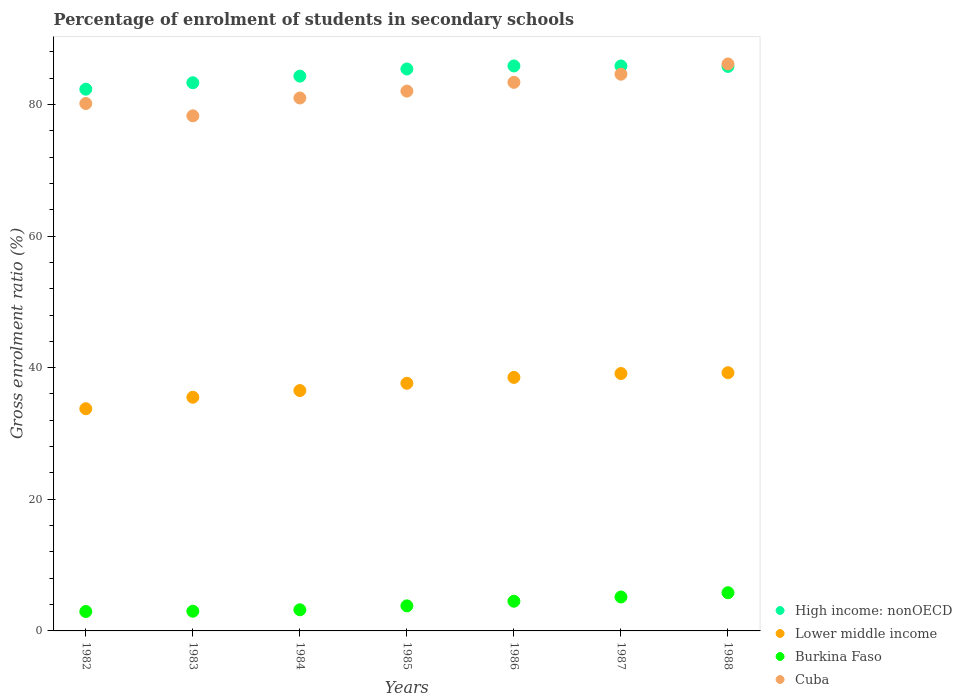How many different coloured dotlines are there?
Ensure brevity in your answer.  4. Is the number of dotlines equal to the number of legend labels?
Your answer should be very brief. Yes. What is the percentage of students enrolled in secondary schools in Burkina Faso in 1985?
Offer a terse response. 3.81. Across all years, what is the maximum percentage of students enrolled in secondary schools in Burkina Faso?
Your response must be concise. 5.81. Across all years, what is the minimum percentage of students enrolled in secondary schools in Lower middle income?
Your answer should be compact. 33.76. In which year was the percentage of students enrolled in secondary schools in Lower middle income maximum?
Provide a succinct answer. 1988. What is the total percentage of students enrolled in secondary schools in Lower middle income in the graph?
Your answer should be compact. 260.27. What is the difference between the percentage of students enrolled in secondary schools in Burkina Faso in 1983 and that in 1988?
Ensure brevity in your answer.  -2.81. What is the difference between the percentage of students enrolled in secondary schools in Cuba in 1986 and the percentage of students enrolled in secondary schools in Lower middle income in 1982?
Your answer should be compact. 49.59. What is the average percentage of students enrolled in secondary schools in High income: nonOECD per year?
Your response must be concise. 84.68. In the year 1984, what is the difference between the percentage of students enrolled in secondary schools in Cuba and percentage of students enrolled in secondary schools in Burkina Faso?
Your response must be concise. 77.76. In how many years, is the percentage of students enrolled in secondary schools in Lower middle income greater than 48 %?
Keep it short and to the point. 0. What is the ratio of the percentage of students enrolled in secondary schools in Lower middle income in 1982 to that in 1984?
Offer a very short reply. 0.92. What is the difference between the highest and the second highest percentage of students enrolled in secondary schools in High income: nonOECD?
Keep it short and to the point. 0. What is the difference between the highest and the lowest percentage of students enrolled in secondary schools in High income: nonOECD?
Offer a terse response. 3.54. Is it the case that in every year, the sum of the percentage of students enrolled in secondary schools in Cuba and percentage of students enrolled in secondary schools in High income: nonOECD  is greater than the sum of percentage of students enrolled in secondary schools in Burkina Faso and percentage of students enrolled in secondary schools in Lower middle income?
Provide a short and direct response. Yes. Is the percentage of students enrolled in secondary schools in Cuba strictly less than the percentage of students enrolled in secondary schools in Burkina Faso over the years?
Provide a succinct answer. No. How many years are there in the graph?
Your response must be concise. 7. What is the difference between two consecutive major ticks on the Y-axis?
Make the answer very short. 20. How are the legend labels stacked?
Offer a terse response. Vertical. What is the title of the graph?
Ensure brevity in your answer.  Percentage of enrolment of students in secondary schools. Does "Kenya" appear as one of the legend labels in the graph?
Provide a short and direct response. No. What is the Gross enrolment ratio (%) of High income: nonOECD in 1982?
Provide a succinct answer. 82.31. What is the Gross enrolment ratio (%) in Lower middle income in 1982?
Your response must be concise. 33.76. What is the Gross enrolment ratio (%) in Burkina Faso in 1982?
Ensure brevity in your answer.  2.95. What is the Gross enrolment ratio (%) in Cuba in 1982?
Give a very brief answer. 80.13. What is the Gross enrolment ratio (%) of High income: nonOECD in 1983?
Give a very brief answer. 83.29. What is the Gross enrolment ratio (%) in Lower middle income in 1983?
Offer a very short reply. 35.5. What is the Gross enrolment ratio (%) in Burkina Faso in 1983?
Your response must be concise. 2.99. What is the Gross enrolment ratio (%) of Cuba in 1983?
Your answer should be compact. 78.26. What is the Gross enrolment ratio (%) of High income: nonOECD in 1984?
Provide a short and direct response. 84.29. What is the Gross enrolment ratio (%) of Lower middle income in 1984?
Keep it short and to the point. 36.52. What is the Gross enrolment ratio (%) in Burkina Faso in 1984?
Provide a succinct answer. 3.21. What is the Gross enrolment ratio (%) of Cuba in 1984?
Provide a succinct answer. 80.97. What is the Gross enrolment ratio (%) of High income: nonOECD in 1985?
Your response must be concise. 85.38. What is the Gross enrolment ratio (%) of Lower middle income in 1985?
Give a very brief answer. 37.63. What is the Gross enrolment ratio (%) of Burkina Faso in 1985?
Ensure brevity in your answer.  3.81. What is the Gross enrolment ratio (%) in Cuba in 1985?
Keep it short and to the point. 82.02. What is the Gross enrolment ratio (%) of High income: nonOECD in 1986?
Keep it short and to the point. 85.84. What is the Gross enrolment ratio (%) of Lower middle income in 1986?
Provide a succinct answer. 38.52. What is the Gross enrolment ratio (%) of Burkina Faso in 1986?
Provide a succinct answer. 4.51. What is the Gross enrolment ratio (%) of Cuba in 1986?
Offer a very short reply. 83.35. What is the Gross enrolment ratio (%) in High income: nonOECD in 1987?
Provide a short and direct response. 85.84. What is the Gross enrolment ratio (%) of Lower middle income in 1987?
Your answer should be very brief. 39.11. What is the Gross enrolment ratio (%) in Burkina Faso in 1987?
Offer a very short reply. 5.16. What is the Gross enrolment ratio (%) of Cuba in 1987?
Provide a succinct answer. 84.59. What is the Gross enrolment ratio (%) in High income: nonOECD in 1988?
Keep it short and to the point. 85.77. What is the Gross enrolment ratio (%) in Lower middle income in 1988?
Your response must be concise. 39.23. What is the Gross enrolment ratio (%) in Burkina Faso in 1988?
Give a very brief answer. 5.81. What is the Gross enrolment ratio (%) in Cuba in 1988?
Offer a terse response. 86.14. Across all years, what is the maximum Gross enrolment ratio (%) in High income: nonOECD?
Offer a very short reply. 85.84. Across all years, what is the maximum Gross enrolment ratio (%) in Lower middle income?
Your response must be concise. 39.23. Across all years, what is the maximum Gross enrolment ratio (%) of Burkina Faso?
Your response must be concise. 5.81. Across all years, what is the maximum Gross enrolment ratio (%) in Cuba?
Make the answer very short. 86.14. Across all years, what is the minimum Gross enrolment ratio (%) in High income: nonOECD?
Offer a very short reply. 82.31. Across all years, what is the minimum Gross enrolment ratio (%) of Lower middle income?
Ensure brevity in your answer.  33.76. Across all years, what is the minimum Gross enrolment ratio (%) of Burkina Faso?
Ensure brevity in your answer.  2.95. Across all years, what is the minimum Gross enrolment ratio (%) of Cuba?
Keep it short and to the point. 78.26. What is the total Gross enrolment ratio (%) of High income: nonOECD in the graph?
Your answer should be compact. 592.73. What is the total Gross enrolment ratio (%) in Lower middle income in the graph?
Keep it short and to the point. 260.27. What is the total Gross enrolment ratio (%) in Burkina Faso in the graph?
Your response must be concise. 28.44. What is the total Gross enrolment ratio (%) in Cuba in the graph?
Make the answer very short. 575.47. What is the difference between the Gross enrolment ratio (%) in High income: nonOECD in 1982 and that in 1983?
Give a very brief answer. -0.98. What is the difference between the Gross enrolment ratio (%) in Lower middle income in 1982 and that in 1983?
Your answer should be very brief. -1.74. What is the difference between the Gross enrolment ratio (%) in Burkina Faso in 1982 and that in 1983?
Your answer should be compact. -0.04. What is the difference between the Gross enrolment ratio (%) of Cuba in 1982 and that in 1983?
Give a very brief answer. 1.87. What is the difference between the Gross enrolment ratio (%) in High income: nonOECD in 1982 and that in 1984?
Ensure brevity in your answer.  -1.98. What is the difference between the Gross enrolment ratio (%) of Lower middle income in 1982 and that in 1984?
Ensure brevity in your answer.  -2.76. What is the difference between the Gross enrolment ratio (%) in Burkina Faso in 1982 and that in 1984?
Your answer should be very brief. -0.26. What is the difference between the Gross enrolment ratio (%) in Cuba in 1982 and that in 1984?
Provide a succinct answer. -0.84. What is the difference between the Gross enrolment ratio (%) in High income: nonOECD in 1982 and that in 1985?
Ensure brevity in your answer.  -3.07. What is the difference between the Gross enrolment ratio (%) in Lower middle income in 1982 and that in 1985?
Make the answer very short. -3.87. What is the difference between the Gross enrolment ratio (%) of Burkina Faso in 1982 and that in 1985?
Your answer should be very brief. -0.85. What is the difference between the Gross enrolment ratio (%) in Cuba in 1982 and that in 1985?
Offer a very short reply. -1.88. What is the difference between the Gross enrolment ratio (%) of High income: nonOECD in 1982 and that in 1986?
Your response must be concise. -3.54. What is the difference between the Gross enrolment ratio (%) in Lower middle income in 1982 and that in 1986?
Provide a succinct answer. -4.76. What is the difference between the Gross enrolment ratio (%) in Burkina Faso in 1982 and that in 1986?
Make the answer very short. -1.56. What is the difference between the Gross enrolment ratio (%) in Cuba in 1982 and that in 1986?
Ensure brevity in your answer.  -3.22. What is the difference between the Gross enrolment ratio (%) in High income: nonOECD in 1982 and that in 1987?
Your answer should be compact. -3.53. What is the difference between the Gross enrolment ratio (%) in Lower middle income in 1982 and that in 1987?
Provide a short and direct response. -5.35. What is the difference between the Gross enrolment ratio (%) in Burkina Faso in 1982 and that in 1987?
Offer a terse response. -2.21. What is the difference between the Gross enrolment ratio (%) in Cuba in 1982 and that in 1987?
Keep it short and to the point. -4.45. What is the difference between the Gross enrolment ratio (%) of High income: nonOECD in 1982 and that in 1988?
Offer a very short reply. -3.46. What is the difference between the Gross enrolment ratio (%) of Lower middle income in 1982 and that in 1988?
Make the answer very short. -5.47. What is the difference between the Gross enrolment ratio (%) in Burkina Faso in 1982 and that in 1988?
Offer a terse response. -2.85. What is the difference between the Gross enrolment ratio (%) of Cuba in 1982 and that in 1988?
Give a very brief answer. -6.01. What is the difference between the Gross enrolment ratio (%) in High income: nonOECD in 1983 and that in 1984?
Make the answer very short. -1. What is the difference between the Gross enrolment ratio (%) in Lower middle income in 1983 and that in 1984?
Your answer should be compact. -1.02. What is the difference between the Gross enrolment ratio (%) of Burkina Faso in 1983 and that in 1984?
Offer a very short reply. -0.22. What is the difference between the Gross enrolment ratio (%) of Cuba in 1983 and that in 1984?
Offer a terse response. -2.71. What is the difference between the Gross enrolment ratio (%) of High income: nonOECD in 1983 and that in 1985?
Your answer should be compact. -2.09. What is the difference between the Gross enrolment ratio (%) of Lower middle income in 1983 and that in 1985?
Make the answer very short. -2.13. What is the difference between the Gross enrolment ratio (%) of Burkina Faso in 1983 and that in 1985?
Offer a very short reply. -0.81. What is the difference between the Gross enrolment ratio (%) in Cuba in 1983 and that in 1985?
Give a very brief answer. -3.76. What is the difference between the Gross enrolment ratio (%) of High income: nonOECD in 1983 and that in 1986?
Ensure brevity in your answer.  -2.55. What is the difference between the Gross enrolment ratio (%) in Lower middle income in 1983 and that in 1986?
Offer a very short reply. -3.02. What is the difference between the Gross enrolment ratio (%) of Burkina Faso in 1983 and that in 1986?
Your answer should be compact. -1.52. What is the difference between the Gross enrolment ratio (%) of Cuba in 1983 and that in 1986?
Ensure brevity in your answer.  -5.09. What is the difference between the Gross enrolment ratio (%) of High income: nonOECD in 1983 and that in 1987?
Your response must be concise. -2.55. What is the difference between the Gross enrolment ratio (%) in Lower middle income in 1983 and that in 1987?
Offer a terse response. -3.61. What is the difference between the Gross enrolment ratio (%) in Burkina Faso in 1983 and that in 1987?
Your response must be concise. -2.17. What is the difference between the Gross enrolment ratio (%) of Cuba in 1983 and that in 1987?
Provide a short and direct response. -6.32. What is the difference between the Gross enrolment ratio (%) of High income: nonOECD in 1983 and that in 1988?
Make the answer very short. -2.48. What is the difference between the Gross enrolment ratio (%) of Lower middle income in 1983 and that in 1988?
Offer a terse response. -3.73. What is the difference between the Gross enrolment ratio (%) of Burkina Faso in 1983 and that in 1988?
Provide a succinct answer. -2.81. What is the difference between the Gross enrolment ratio (%) of Cuba in 1983 and that in 1988?
Your answer should be compact. -7.88. What is the difference between the Gross enrolment ratio (%) of High income: nonOECD in 1984 and that in 1985?
Give a very brief answer. -1.09. What is the difference between the Gross enrolment ratio (%) of Lower middle income in 1984 and that in 1985?
Provide a short and direct response. -1.11. What is the difference between the Gross enrolment ratio (%) in Burkina Faso in 1984 and that in 1985?
Keep it short and to the point. -0.59. What is the difference between the Gross enrolment ratio (%) in Cuba in 1984 and that in 1985?
Provide a short and direct response. -1.04. What is the difference between the Gross enrolment ratio (%) of High income: nonOECD in 1984 and that in 1986?
Give a very brief answer. -1.55. What is the difference between the Gross enrolment ratio (%) in Lower middle income in 1984 and that in 1986?
Offer a very short reply. -2. What is the difference between the Gross enrolment ratio (%) of Burkina Faso in 1984 and that in 1986?
Provide a short and direct response. -1.3. What is the difference between the Gross enrolment ratio (%) of Cuba in 1984 and that in 1986?
Offer a very short reply. -2.38. What is the difference between the Gross enrolment ratio (%) in High income: nonOECD in 1984 and that in 1987?
Your response must be concise. -1.55. What is the difference between the Gross enrolment ratio (%) of Lower middle income in 1984 and that in 1987?
Offer a terse response. -2.59. What is the difference between the Gross enrolment ratio (%) of Burkina Faso in 1984 and that in 1987?
Provide a succinct answer. -1.94. What is the difference between the Gross enrolment ratio (%) in Cuba in 1984 and that in 1987?
Your response must be concise. -3.61. What is the difference between the Gross enrolment ratio (%) of High income: nonOECD in 1984 and that in 1988?
Your answer should be compact. -1.48. What is the difference between the Gross enrolment ratio (%) of Lower middle income in 1984 and that in 1988?
Ensure brevity in your answer.  -2.71. What is the difference between the Gross enrolment ratio (%) of Burkina Faso in 1984 and that in 1988?
Offer a terse response. -2.59. What is the difference between the Gross enrolment ratio (%) in Cuba in 1984 and that in 1988?
Your answer should be very brief. -5.17. What is the difference between the Gross enrolment ratio (%) in High income: nonOECD in 1985 and that in 1986?
Your response must be concise. -0.46. What is the difference between the Gross enrolment ratio (%) in Lower middle income in 1985 and that in 1986?
Provide a short and direct response. -0.89. What is the difference between the Gross enrolment ratio (%) of Burkina Faso in 1985 and that in 1986?
Ensure brevity in your answer.  -0.71. What is the difference between the Gross enrolment ratio (%) in Cuba in 1985 and that in 1986?
Provide a succinct answer. -1.33. What is the difference between the Gross enrolment ratio (%) of High income: nonOECD in 1985 and that in 1987?
Give a very brief answer. -0.46. What is the difference between the Gross enrolment ratio (%) of Lower middle income in 1985 and that in 1987?
Your response must be concise. -1.48. What is the difference between the Gross enrolment ratio (%) in Burkina Faso in 1985 and that in 1987?
Make the answer very short. -1.35. What is the difference between the Gross enrolment ratio (%) in Cuba in 1985 and that in 1987?
Provide a short and direct response. -2.57. What is the difference between the Gross enrolment ratio (%) of High income: nonOECD in 1985 and that in 1988?
Provide a succinct answer. -0.39. What is the difference between the Gross enrolment ratio (%) of Lower middle income in 1985 and that in 1988?
Offer a very short reply. -1.61. What is the difference between the Gross enrolment ratio (%) of Burkina Faso in 1985 and that in 1988?
Offer a very short reply. -2. What is the difference between the Gross enrolment ratio (%) in Cuba in 1985 and that in 1988?
Offer a very short reply. -4.13. What is the difference between the Gross enrolment ratio (%) in High income: nonOECD in 1986 and that in 1987?
Offer a very short reply. 0.01. What is the difference between the Gross enrolment ratio (%) in Lower middle income in 1986 and that in 1987?
Provide a short and direct response. -0.59. What is the difference between the Gross enrolment ratio (%) in Burkina Faso in 1986 and that in 1987?
Offer a very short reply. -0.64. What is the difference between the Gross enrolment ratio (%) of Cuba in 1986 and that in 1987?
Make the answer very short. -1.23. What is the difference between the Gross enrolment ratio (%) in High income: nonOECD in 1986 and that in 1988?
Offer a terse response. 0.07. What is the difference between the Gross enrolment ratio (%) of Lower middle income in 1986 and that in 1988?
Make the answer very short. -0.71. What is the difference between the Gross enrolment ratio (%) of Burkina Faso in 1986 and that in 1988?
Give a very brief answer. -1.29. What is the difference between the Gross enrolment ratio (%) in Cuba in 1986 and that in 1988?
Provide a succinct answer. -2.79. What is the difference between the Gross enrolment ratio (%) of High income: nonOECD in 1987 and that in 1988?
Provide a succinct answer. 0.07. What is the difference between the Gross enrolment ratio (%) of Lower middle income in 1987 and that in 1988?
Make the answer very short. -0.12. What is the difference between the Gross enrolment ratio (%) of Burkina Faso in 1987 and that in 1988?
Make the answer very short. -0.65. What is the difference between the Gross enrolment ratio (%) of Cuba in 1987 and that in 1988?
Keep it short and to the point. -1.56. What is the difference between the Gross enrolment ratio (%) of High income: nonOECD in 1982 and the Gross enrolment ratio (%) of Lower middle income in 1983?
Your answer should be compact. 46.81. What is the difference between the Gross enrolment ratio (%) in High income: nonOECD in 1982 and the Gross enrolment ratio (%) in Burkina Faso in 1983?
Ensure brevity in your answer.  79.32. What is the difference between the Gross enrolment ratio (%) in High income: nonOECD in 1982 and the Gross enrolment ratio (%) in Cuba in 1983?
Give a very brief answer. 4.05. What is the difference between the Gross enrolment ratio (%) of Lower middle income in 1982 and the Gross enrolment ratio (%) of Burkina Faso in 1983?
Offer a terse response. 30.77. What is the difference between the Gross enrolment ratio (%) in Lower middle income in 1982 and the Gross enrolment ratio (%) in Cuba in 1983?
Make the answer very short. -44.5. What is the difference between the Gross enrolment ratio (%) in Burkina Faso in 1982 and the Gross enrolment ratio (%) in Cuba in 1983?
Your response must be concise. -75.31. What is the difference between the Gross enrolment ratio (%) in High income: nonOECD in 1982 and the Gross enrolment ratio (%) in Lower middle income in 1984?
Ensure brevity in your answer.  45.79. What is the difference between the Gross enrolment ratio (%) of High income: nonOECD in 1982 and the Gross enrolment ratio (%) of Burkina Faso in 1984?
Provide a succinct answer. 79.1. What is the difference between the Gross enrolment ratio (%) in High income: nonOECD in 1982 and the Gross enrolment ratio (%) in Cuba in 1984?
Keep it short and to the point. 1.34. What is the difference between the Gross enrolment ratio (%) of Lower middle income in 1982 and the Gross enrolment ratio (%) of Burkina Faso in 1984?
Your answer should be very brief. 30.55. What is the difference between the Gross enrolment ratio (%) in Lower middle income in 1982 and the Gross enrolment ratio (%) in Cuba in 1984?
Ensure brevity in your answer.  -47.21. What is the difference between the Gross enrolment ratio (%) of Burkina Faso in 1982 and the Gross enrolment ratio (%) of Cuba in 1984?
Provide a succinct answer. -78.02. What is the difference between the Gross enrolment ratio (%) in High income: nonOECD in 1982 and the Gross enrolment ratio (%) in Lower middle income in 1985?
Provide a succinct answer. 44.68. What is the difference between the Gross enrolment ratio (%) in High income: nonOECD in 1982 and the Gross enrolment ratio (%) in Burkina Faso in 1985?
Keep it short and to the point. 78.5. What is the difference between the Gross enrolment ratio (%) in High income: nonOECD in 1982 and the Gross enrolment ratio (%) in Cuba in 1985?
Provide a succinct answer. 0.29. What is the difference between the Gross enrolment ratio (%) of Lower middle income in 1982 and the Gross enrolment ratio (%) of Burkina Faso in 1985?
Offer a terse response. 29.96. What is the difference between the Gross enrolment ratio (%) in Lower middle income in 1982 and the Gross enrolment ratio (%) in Cuba in 1985?
Your response must be concise. -48.26. What is the difference between the Gross enrolment ratio (%) of Burkina Faso in 1982 and the Gross enrolment ratio (%) of Cuba in 1985?
Keep it short and to the point. -79.07. What is the difference between the Gross enrolment ratio (%) in High income: nonOECD in 1982 and the Gross enrolment ratio (%) in Lower middle income in 1986?
Offer a terse response. 43.79. What is the difference between the Gross enrolment ratio (%) in High income: nonOECD in 1982 and the Gross enrolment ratio (%) in Burkina Faso in 1986?
Give a very brief answer. 77.8. What is the difference between the Gross enrolment ratio (%) of High income: nonOECD in 1982 and the Gross enrolment ratio (%) of Cuba in 1986?
Provide a succinct answer. -1.04. What is the difference between the Gross enrolment ratio (%) of Lower middle income in 1982 and the Gross enrolment ratio (%) of Burkina Faso in 1986?
Make the answer very short. 29.25. What is the difference between the Gross enrolment ratio (%) of Lower middle income in 1982 and the Gross enrolment ratio (%) of Cuba in 1986?
Offer a terse response. -49.59. What is the difference between the Gross enrolment ratio (%) in Burkina Faso in 1982 and the Gross enrolment ratio (%) in Cuba in 1986?
Provide a succinct answer. -80.4. What is the difference between the Gross enrolment ratio (%) of High income: nonOECD in 1982 and the Gross enrolment ratio (%) of Lower middle income in 1987?
Keep it short and to the point. 43.2. What is the difference between the Gross enrolment ratio (%) of High income: nonOECD in 1982 and the Gross enrolment ratio (%) of Burkina Faso in 1987?
Your response must be concise. 77.15. What is the difference between the Gross enrolment ratio (%) of High income: nonOECD in 1982 and the Gross enrolment ratio (%) of Cuba in 1987?
Offer a terse response. -2.28. What is the difference between the Gross enrolment ratio (%) in Lower middle income in 1982 and the Gross enrolment ratio (%) in Burkina Faso in 1987?
Keep it short and to the point. 28.6. What is the difference between the Gross enrolment ratio (%) of Lower middle income in 1982 and the Gross enrolment ratio (%) of Cuba in 1987?
Ensure brevity in your answer.  -50.82. What is the difference between the Gross enrolment ratio (%) of Burkina Faso in 1982 and the Gross enrolment ratio (%) of Cuba in 1987?
Offer a terse response. -81.63. What is the difference between the Gross enrolment ratio (%) of High income: nonOECD in 1982 and the Gross enrolment ratio (%) of Lower middle income in 1988?
Offer a very short reply. 43.08. What is the difference between the Gross enrolment ratio (%) of High income: nonOECD in 1982 and the Gross enrolment ratio (%) of Burkina Faso in 1988?
Provide a succinct answer. 76.5. What is the difference between the Gross enrolment ratio (%) of High income: nonOECD in 1982 and the Gross enrolment ratio (%) of Cuba in 1988?
Keep it short and to the point. -3.83. What is the difference between the Gross enrolment ratio (%) of Lower middle income in 1982 and the Gross enrolment ratio (%) of Burkina Faso in 1988?
Offer a very short reply. 27.96. What is the difference between the Gross enrolment ratio (%) in Lower middle income in 1982 and the Gross enrolment ratio (%) in Cuba in 1988?
Provide a short and direct response. -52.38. What is the difference between the Gross enrolment ratio (%) of Burkina Faso in 1982 and the Gross enrolment ratio (%) of Cuba in 1988?
Make the answer very short. -83.19. What is the difference between the Gross enrolment ratio (%) of High income: nonOECD in 1983 and the Gross enrolment ratio (%) of Lower middle income in 1984?
Make the answer very short. 46.77. What is the difference between the Gross enrolment ratio (%) in High income: nonOECD in 1983 and the Gross enrolment ratio (%) in Burkina Faso in 1984?
Keep it short and to the point. 80.08. What is the difference between the Gross enrolment ratio (%) of High income: nonOECD in 1983 and the Gross enrolment ratio (%) of Cuba in 1984?
Offer a terse response. 2.32. What is the difference between the Gross enrolment ratio (%) in Lower middle income in 1983 and the Gross enrolment ratio (%) in Burkina Faso in 1984?
Your answer should be very brief. 32.29. What is the difference between the Gross enrolment ratio (%) of Lower middle income in 1983 and the Gross enrolment ratio (%) of Cuba in 1984?
Provide a short and direct response. -45.47. What is the difference between the Gross enrolment ratio (%) in Burkina Faso in 1983 and the Gross enrolment ratio (%) in Cuba in 1984?
Offer a terse response. -77.98. What is the difference between the Gross enrolment ratio (%) of High income: nonOECD in 1983 and the Gross enrolment ratio (%) of Lower middle income in 1985?
Offer a very short reply. 45.66. What is the difference between the Gross enrolment ratio (%) of High income: nonOECD in 1983 and the Gross enrolment ratio (%) of Burkina Faso in 1985?
Offer a terse response. 79.48. What is the difference between the Gross enrolment ratio (%) in High income: nonOECD in 1983 and the Gross enrolment ratio (%) in Cuba in 1985?
Make the answer very short. 1.27. What is the difference between the Gross enrolment ratio (%) in Lower middle income in 1983 and the Gross enrolment ratio (%) in Burkina Faso in 1985?
Keep it short and to the point. 31.7. What is the difference between the Gross enrolment ratio (%) of Lower middle income in 1983 and the Gross enrolment ratio (%) of Cuba in 1985?
Your answer should be compact. -46.52. What is the difference between the Gross enrolment ratio (%) of Burkina Faso in 1983 and the Gross enrolment ratio (%) of Cuba in 1985?
Provide a short and direct response. -79.03. What is the difference between the Gross enrolment ratio (%) of High income: nonOECD in 1983 and the Gross enrolment ratio (%) of Lower middle income in 1986?
Ensure brevity in your answer.  44.77. What is the difference between the Gross enrolment ratio (%) of High income: nonOECD in 1983 and the Gross enrolment ratio (%) of Burkina Faso in 1986?
Your answer should be compact. 78.78. What is the difference between the Gross enrolment ratio (%) of High income: nonOECD in 1983 and the Gross enrolment ratio (%) of Cuba in 1986?
Offer a very short reply. -0.06. What is the difference between the Gross enrolment ratio (%) in Lower middle income in 1983 and the Gross enrolment ratio (%) in Burkina Faso in 1986?
Your response must be concise. 30.99. What is the difference between the Gross enrolment ratio (%) in Lower middle income in 1983 and the Gross enrolment ratio (%) in Cuba in 1986?
Offer a terse response. -47.85. What is the difference between the Gross enrolment ratio (%) of Burkina Faso in 1983 and the Gross enrolment ratio (%) of Cuba in 1986?
Offer a terse response. -80.36. What is the difference between the Gross enrolment ratio (%) of High income: nonOECD in 1983 and the Gross enrolment ratio (%) of Lower middle income in 1987?
Offer a terse response. 44.18. What is the difference between the Gross enrolment ratio (%) of High income: nonOECD in 1983 and the Gross enrolment ratio (%) of Burkina Faso in 1987?
Give a very brief answer. 78.13. What is the difference between the Gross enrolment ratio (%) of High income: nonOECD in 1983 and the Gross enrolment ratio (%) of Cuba in 1987?
Your response must be concise. -1.3. What is the difference between the Gross enrolment ratio (%) in Lower middle income in 1983 and the Gross enrolment ratio (%) in Burkina Faso in 1987?
Provide a succinct answer. 30.34. What is the difference between the Gross enrolment ratio (%) of Lower middle income in 1983 and the Gross enrolment ratio (%) of Cuba in 1987?
Offer a very short reply. -49.08. What is the difference between the Gross enrolment ratio (%) in Burkina Faso in 1983 and the Gross enrolment ratio (%) in Cuba in 1987?
Ensure brevity in your answer.  -81.59. What is the difference between the Gross enrolment ratio (%) of High income: nonOECD in 1983 and the Gross enrolment ratio (%) of Lower middle income in 1988?
Provide a short and direct response. 44.06. What is the difference between the Gross enrolment ratio (%) of High income: nonOECD in 1983 and the Gross enrolment ratio (%) of Burkina Faso in 1988?
Provide a short and direct response. 77.48. What is the difference between the Gross enrolment ratio (%) of High income: nonOECD in 1983 and the Gross enrolment ratio (%) of Cuba in 1988?
Ensure brevity in your answer.  -2.85. What is the difference between the Gross enrolment ratio (%) in Lower middle income in 1983 and the Gross enrolment ratio (%) in Burkina Faso in 1988?
Your answer should be very brief. 29.7. What is the difference between the Gross enrolment ratio (%) in Lower middle income in 1983 and the Gross enrolment ratio (%) in Cuba in 1988?
Make the answer very short. -50.64. What is the difference between the Gross enrolment ratio (%) in Burkina Faso in 1983 and the Gross enrolment ratio (%) in Cuba in 1988?
Offer a terse response. -83.15. What is the difference between the Gross enrolment ratio (%) in High income: nonOECD in 1984 and the Gross enrolment ratio (%) in Lower middle income in 1985?
Your answer should be compact. 46.67. What is the difference between the Gross enrolment ratio (%) in High income: nonOECD in 1984 and the Gross enrolment ratio (%) in Burkina Faso in 1985?
Provide a succinct answer. 80.49. What is the difference between the Gross enrolment ratio (%) in High income: nonOECD in 1984 and the Gross enrolment ratio (%) in Cuba in 1985?
Offer a terse response. 2.28. What is the difference between the Gross enrolment ratio (%) of Lower middle income in 1984 and the Gross enrolment ratio (%) of Burkina Faso in 1985?
Offer a very short reply. 32.72. What is the difference between the Gross enrolment ratio (%) of Lower middle income in 1984 and the Gross enrolment ratio (%) of Cuba in 1985?
Provide a succinct answer. -45.5. What is the difference between the Gross enrolment ratio (%) in Burkina Faso in 1984 and the Gross enrolment ratio (%) in Cuba in 1985?
Offer a terse response. -78.81. What is the difference between the Gross enrolment ratio (%) of High income: nonOECD in 1984 and the Gross enrolment ratio (%) of Lower middle income in 1986?
Keep it short and to the point. 45.77. What is the difference between the Gross enrolment ratio (%) in High income: nonOECD in 1984 and the Gross enrolment ratio (%) in Burkina Faso in 1986?
Your response must be concise. 79.78. What is the difference between the Gross enrolment ratio (%) of High income: nonOECD in 1984 and the Gross enrolment ratio (%) of Cuba in 1986?
Ensure brevity in your answer.  0.94. What is the difference between the Gross enrolment ratio (%) in Lower middle income in 1984 and the Gross enrolment ratio (%) in Burkina Faso in 1986?
Your answer should be compact. 32.01. What is the difference between the Gross enrolment ratio (%) of Lower middle income in 1984 and the Gross enrolment ratio (%) of Cuba in 1986?
Offer a terse response. -46.83. What is the difference between the Gross enrolment ratio (%) in Burkina Faso in 1984 and the Gross enrolment ratio (%) in Cuba in 1986?
Keep it short and to the point. -80.14. What is the difference between the Gross enrolment ratio (%) of High income: nonOECD in 1984 and the Gross enrolment ratio (%) of Lower middle income in 1987?
Your answer should be compact. 45.19. What is the difference between the Gross enrolment ratio (%) of High income: nonOECD in 1984 and the Gross enrolment ratio (%) of Burkina Faso in 1987?
Provide a succinct answer. 79.14. What is the difference between the Gross enrolment ratio (%) of High income: nonOECD in 1984 and the Gross enrolment ratio (%) of Cuba in 1987?
Provide a short and direct response. -0.29. What is the difference between the Gross enrolment ratio (%) of Lower middle income in 1984 and the Gross enrolment ratio (%) of Burkina Faso in 1987?
Provide a short and direct response. 31.36. What is the difference between the Gross enrolment ratio (%) in Lower middle income in 1984 and the Gross enrolment ratio (%) in Cuba in 1987?
Provide a succinct answer. -48.06. What is the difference between the Gross enrolment ratio (%) of Burkina Faso in 1984 and the Gross enrolment ratio (%) of Cuba in 1987?
Ensure brevity in your answer.  -81.37. What is the difference between the Gross enrolment ratio (%) of High income: nonOECD in 1984 and the Gross enrolment ratio (%) of Lower middle income in 1988?
Keep it short and to the point. 45.06. What is the difference between the Gross enrolment ratio (%) of High income: nonOECD in 1984 and the Gross enrolment ratio (%) of Burkina Faso in 1988?
Your answer should be very brief. 78.49. What is the difference between the Gross enrolment ratio (%) in High income: nonOECD in 1984 and the Gross enrolment ratio (%) in Cuba in 1988?
Your answer should be very brief. -1.85. What is the difference between the Gross enrolment ratio (%) of Lower middle income in 1984 and the Gross enrolment ratio (%) of Burkina Faso in 1988?
Provide a short and direct response. 30.72. What is the difference between the Gross enrolment ratio (%) in Lower middle income in 1984 and the Gross enrolment ratio (%) in Cuba in 1988?
Provide a succinct answer. -49.62. What is the difference between the Gross enrolment ratio (%) in Burkina Faso in 1984 and the Gross enrolment ratio (%) in Cuba in 1988?
Provide a succinct answer. -82.93. What is the difference between the Gross enrolment ratio (%) in High income: nonOECD in 1985 and the Gross enrolment ratio (%) in Lower middle income in 1986?
Offer a very short reply. 46.86. What is the difference between the Gross enrolment ratio (%) of High income: nonOECD in 1985 and the Gross enrolment ratio (%) of Burkina Faso in 1986?
Make the answer very short. 80.87. What is the difference between the Gross enrolment ratio (%) of High income: nonOECD in 1985 and the Gross enrolment ratio (%) of Cuba in 1986?
Provide a succinct answer. 2.03. What is the difference between the Gross enrolment ratio (%) of Lower middle income in 1985 and the Gross enrolment ratio (%) of Burkina Faso in 1986?
Your response must be concise. 33.11. What is the difference between the Gross enrolment ratio (%) of Lower middle income in 1985 and the Gross enrolment ratio (%) of Cuba in 1986?
Your response must be concise. -45.72. What is the difference between the Gross enrolment ratio (%) in Burkina Faso in 1985 and the Gross enrolment ratio (%) in Cuba in 1986?
Give a very brief answer. -79.55. What is the difference between the Gross enrolment ratio (%) in High income: nonOECD in 1985 and the Gross enrolment ratio (%) in Lower middle income in 1987?
Offer a very short reply. 46.27. What is the difference between the Gross enrolment ratio (%) in High income: nonOECD in 1985 and the Gross enrolment ratio (%) in Burkina Faso in 1987?
Offer a very short reply. 80.22. What is the difference between the Gross enrolment ratio (%) of High income: nonOECD in 1985 and the Gross enrolment ratio (%) of Cuba in 1987?
Your response must be concise. 0.79. What is the difference between the Gross enrolment ratio (%) in Lower middle income in 1985 and the Gross enrolment ratio (%) in Burkina Faso in 1987?
Give a very brief answer. 32.47. What is the difference between the Gross enrolment ratio (%) in Lower middle income in 1985 and the Gross enrolment ratio (%) in Cuba in 1987?
Your response must be concise. -46.96. What is the difference between the Gross enrolment ratio (%) of Burkina Faso in 1985 and the Gross enrolment ratio (%) of Cuba in 1987?
Keep it short and to the point. -80.78. What is the difference between the Gross enrolment ratio (%) of High income: nonOECD in 1985 and the Gross enrolment ratio (%) of Lower middle income in 1988?
Provide a short and direct response. 46.15. What is the difference between the Gross enrolment ratio (%) in High income: nonOECD in 1985 and the Gross enrolment ratio (%) in Burkina Faso in 1988?
Ensure brevity in your answer.  79.58. What is the difference between the Gross enrolment ratio (%) in High income: nonOECD in 1985 and the Gross enrolment ratio (%) in Cuba in 1988?
Your response must be concise. -0.76. What is the difference between the Gross enrolment ratio (%) of Lower middle income in 1985 and the Gross enrolment ratio (%) of Burkina Faso in 1988?
Provide a short and direct response. 31.82. What is the difference between the Gross enrolment ratio (%) of Lower middle income in 1985 and the Gross enrolment ratio (%) of Cuba in 1988?
Your response must be concise. -48.52. What is the difference between the Gross enrolment ratio (%) of Burkina Faso in 1985 and the Gross enrolment ratio (%) of Cuba in 1988?
Your answer should be very brief. -82.34. What is the difference between the Gross enrolment ratio (%) in High income: nonOECD in 1986 and the Gross enrolment ratio (%) in Lower middle income in 1987?
Make the answer very short. 46.74. What is the difference between the Gross enrolment ratio (%) of High income: nonOECD in 1986 and the Gross enrolment ratio (%) of Burkina Faso in 1987?
Ensure brevity in your answer.  80.69. What is the difference between the Gross enrolment ratio (%) in High income: nonOECD in 1986 and the Gross enrolment ratio (%) in Cuba in 1987?
Your answer should be very brief. 1.26. What is the difference between the Gross enrolment ratio (%) in Lower middle income in 1986 and the Gross enrolment ratio (%) in Burkina Faso in 1987?
Your answer should be compact. 33.36. What is the difference between the Gross enrolment ratio (%) of Lower middle income in 1986 and the Gross enrolment ratio (%) of Cuba in 1987?
Provide a succinct answer. -46.07. What is the difference between the Gross enrolment ratio (%) in Burkina Faso in 1986 and the Gross enrolment ratio (%) in Cuba in 1987?
Make the answer very short. -80.07. What is the difference between the Gross enrolment ratio (%) of High income: nonOECD in 1986 and the Gross enrolment ratio (%) of Lower middle income in 1988?
Your answer should be very brief. 46.61. What is the difference between the Gross enrolment ratio (%) of High income: nonOECD in 1986 and the Gross enrolment ratio (%) of Burkina Faso in 1988?
Offer a terse response. 80.04. What is the difference between the Gross enrolment ratio (%) of High income: nonOECD in 1986 and the Gross enrolment ratio (%) of Cuba in 1988?
Make the answer very short. -0.3. What is the difference between the Gross enrolment ratio (%) of Lower middle income in 1986 and the Gross enrolment ratio (%) of Burkina Faso in 1988?
Make the answer very short. 32.71. What is the difference between the Gross enrolment ratio (%) of Lower middle income in 1986 and the Gross enrolment ratio (%) of Cuba in 1988?
Make the answer very short. -47.62. What is the difference between the Gross enrolment ratio (%) of Burkina Faso in 1986 and the Gross enrolment ratio (%) of Cuba in 1988?
Give a very brief answer. -81.63. What is the difference between the Gross enrolment ratio (%) of High income: nonOECD in 1987 and the Gross enrolment ratio (%) of Lower middle income in 1988?
Give a very brief answer. 46.61. What is the difference between the Gross enrolment ratio (%) in High income: nonOECD in 1987 and the Gross enrolment ratio (%) in Burkina Faso in 1988?
Your answer should be compact. 80.03. What is the difference between the Gross enrolment ratio (%) in High income: nonOECD in 1987 and the Gross enrolment ratio (%) in Cuba in 1988?
Keep it short and to the point. -0.3. What is the difference between the Gross enrolment ratio (%) in Lower middle income in 1987 and the Gross enrolment ratio (%) in Burkina Faso in 1988?
Provide a succinct answer. 33.3. What is the difference between the Gross enrolment ratio (%) of Lower middle income in 1987 and the Gross enrolment ratio (%) of Cuba in 1988?
Give a very brief answer. -47.04. What is the difference between the Gross enrolment ratio (%) in Burkina Faso in 1987 and the Gross enrolment ratio (%) in Cuba in 1988?
Provide a succinct answer. -80.99. What is the average Gross enrolment ratio (%) in High income: nonOECD per year?
Offer a terse response. 84.68. What is the average Gross enrolment ratio (%) of Lower middle income per year?
Your answer should be very brief. 37.18. What is the average Gross enrolment ratio (%) in Burkina Faso per year?
Your answer should be very brief. 4.06. What is the average Gross enrolment ratio (%) in Cuba per year?
Ensure brevity in your answer.  82.21. In the year 1982, what is the difference between the Gross enrolment ratio (%) of High income: nonOECD and Gross enrolment ratio (%) of Lower middle income?
Your answer should be very brief. 48.55. In the year 1982, what is the difference between the Gross enrolment ratio (%) in High income: nonOECD and Gross enrolment ratio (%) in Burkina Faso?
Ensure brevity in your answer.  79.36. In the year 1982, what is the difference between the Gross enrolment ratio (%) in High income: nonOECD and Gross enrolment ratio (%) in Cuba?
Give a very brief answer. 2.18. In the year 1982, what is the difference between the Gross enrolment ratio (%) in Lower middle income and Gross enrolment ratio (%) in Burkina Faso?
Your answer should be very brief. 30.81. In the year 1982, what is the difference between the Gross enrolment ratio (%) of Lower middle income and Gross enrolment ratio (%) of Cuba?
Provide a short and direct response. -46.37. In the year 1982, what is the difference between the Gross enrolment ratio (%) in Burkina Faso and Gross enrolment ratio (%) in Cuba?
Give a very brief answer. -77.18. In the year 1983, what is the difference between the Gross enrolment ratio (%) in High income: nonOECD and Gross enrolment ratio (%) in Lower middle income?
Offer a very short reply. 47.79. In the year 1983, what is the difference between the Gross enrolment ratio (%) in High income: nonOECD and Gross enrolment ratio (%) in Burkina Faso?
Your response must be concise. 80.3. In the year 1983, what is the difference between the Gross enrolment ratio (%) of High income: nonOECD and Gross enrolment ratio (%) of Cuba?
Make the answer very short. 5.03. In the year 1983, what is the difference between the Gross enrolment ratio (%) in Lower middle income and Gross enrolment ratio (%) in Burkina Faso?
Provide a succinct answer. 32.51. In the year 1983, what is the difference between the Gross enrolment ratio (%) of Lower middle income and Gross enrolment ratio (%) of Cuba?
Your response must be concise. -42.76. In the year 1983, what is the difference between the Gross enrolment ratio (%) of Burkina Faso and Gross enrolment ratio (%) of Cuba?
Offer a very short reply. -75.27. In the year 1984, what is the difference between the Gross enrolment ratio (%) in High income: nonOECD and Gross enrolment ratio (%) in Lower middle income?
Offer a terse response. 47.77. In the year 1984, what is the difference between the Gross enrolment ratio (%) in High income: nonOECD and Gross enrolment ratio (%) in Burkina Faso?
Offer a terse response. 81.08. In the year 1984, what is the difference between the Gross enrolment ratio (%) of High income: nonOECD and Gross enrolment ratio (%) of Cuba?
Offer a very short reply. 3.32. In the year 1984, what is the difference between the Gross enrolment ratio (%) of Lower middle income and Gross enrolment ratio (%) of Burkina Faso?
Provide a succinct answer. 33.31. In the year 1984, what is the difference between the Gross enrolment ratio (%) in Lower middle income and Gross enrolment ratio (%) in Cuba?
Give a very brief answer. -44.45. In the year 1984, what is the difference between the Gross enrolment ratio (%) in Burkina Faso and Gross enrolment ratio (%) in Cuba?
Provide a succinct answer. -77.76. In the year 1985, what is the difference between the Gross enrolment ratio (%) in High income: nonOECD and Gross enrolment ratio (%) in Lower middle income?
Provide a succinct answer. 47.75. In the year 1985, what is the difference between the Gross enrolment ratio (%) in High income: nonOECD and Gross enrolment ratio (%) in Burkina Faso?
Make the answer very short. 81.57. In the year 1985, what is the difference between the Gross enrolment ratio (%) in High income: nonOECD and Gross enrolment ratio (%) in Cuba?
Your answer should be very brief. 3.36. In the year 1985, what is the difference between the Gross enrolment ratio (%) in Lower middle income and Gross enrolment ratio (%) in Burkina Faso?
Ensure brevity in your answer.  33.82. In the year 1985, what is the difference between the Gross enrolment ratio (%) of Lower middle income and Gross enrolment ratio (%) of Cuba?
Your response must be concise. -44.39. In the year 1985, what is the difference between the Gross enrolment ratio (%) in Burkina Faso and Gross enrolment ratio (%) in Cuba?
Give a very brief answer. -78.21. In the year 1986, what is the difference between the Gross enrolment ratio (%) in High income: nonOECD and Gross enrolment ratio (%) in Lower middle income?
Your response must be concise. 47.33. In the year 1986, what is the difference between the Gross enrolment ratio (%) of High income: nonOECD and Gross enrolment ratio (%) of Burkina Faso?
Provide a succinct answer. 81.33. In the year 1986, what is the difference between the Gross enrolment ratio (%) in High income: nonOECD and Gross enrolment ratio (%) in Cuba?
Provide a succinct answer. 2.49. In the year 1986, what is the difference between the Gross enrolment ratio (%) of Lower middle income and Gross enrolment ratio (%) of Burkina Faso?
Give a very brief answer. 34.01. In the year 1986, what is the difference between the Gross enrolment ratio (%) in Lower middle income and Gross enrolment ratio (%) in Cuba?
Your response must be concise. -44.83. In the year 1986, what is the difference between the Gross enrolment ratio (%) in Burkina Faso and Gross enrolment ratio (%) in Cuba?
Your response must be concise. -78.84. In the year 1987, what is the difference between the Gross enrolment ratio (%) in High income: nonOECD and Gross enrolment ratio (%) in Lower middle income?
Your answer should be very brief. 46.73. In the year 1987, what is the difference between the Gross enrolment ratio (%) of High income: nonOECD and Gross enrolment ratio (%) of Burkina Faso?
Keep it short and to the point. 80.68. In the year 1987, what is the difference between the Gross enrolment ratio (%) in High income: nonOECD and Gross enrolment ratio (%) in Cuba?
Give a very brief answer. 1.25. In the year 1987, what is the difference between the Gross enrolment ratio (%) in Lower middle income and Gross enrolment ratio (%) in Burkina Faso?
Offer a terse response. 33.95. In the year 1987, what is the difference between the Gross enrolment ratio (%) of Lower middle income and Gross enrolment ratio (%) of Cuba?
Make the answer very short. -45.48. In the year 1987, what is the difference between the Gross enrolment ratio (%) in Burkina Faso and Gross enrolment ratio (%) in Cuba?
Ensure brevity in your answer.  -79.43. In the year 1988, what is the difference between the Gross enrolment ratio (%) of High income: nonOECD and Gross enrolment ratio (%) of Lower middle income?
Your response must be concise. 46.54. In the year 1988, what is the difference between the Gross enrolment ratio (%) of High income: nonOECD and Gross enrolment ratio (%) of Burkina Faso?
Your answer should be compact. 79.97. In the year 1988, what is the difference between the Gross enrolment ratio (%) of High income: nonOECD and Gross enrolment ratio (%) of Cuba?
Offer a terse response. -0.37. In the year 1988, what is the difference between the Gross enrolment ratio (%) in Lower middle income and Gross enrolment ratio (%) in Burkina Faso?
Offer a very short reply. 33.43. In the year 1988, what is the difference between the Gross enrolment ratio (%) of Lower middle income and Gross enrolment ratio (%) of Cuba?
Make the answer very short. -46.91. In the year 1988, what is the difference between the Gross enrolment ratio (%) in Burkina Faso and Gross enrolment ratio (%) in Cuba?
Ensure brevity in your answer.  -80.34. What is the ratio of the Gross enrolment ratio (%) of Lower middle income in 1982 to that in 1983?
Keep it short and to the point. 0.95. What is the ratio of the Gross enrolment ratio (%) in Burkina Faso in 1982 to that in 1983?
Provide a short and direct response. 0.99. What is the ratio of the Gross enrolment ratio (%) of Cuba in 1982 to that in 1983?
Keep it short and to the point. 1.02. What is the ratio of the Gross enrolment ratio (%) of High income: nonOECD in 1982 to that in 1984?
Provide a short and direct response. 0.98. What is the ratio of the Gross enrolment ratio (%) in Lower middle income in 1982 to that in 1984?
Your response must be concise. 0.92. What is the ratio of the Gross enrolment ratio (%) of Burkina Faso in 1982 to that in 1984?
Provide a succinct answer. 0.92. What is the ratio of the Gross enrolment ratio (%) of Cuba in 1982 to that in 1984?
Ensure brevity in your answer.  0.99. What is the ratio of the Gross enrolment ratio (%) of High income: nonOECD in 1982 to that in 1985?
Offer a very short reply. 0.96. What is the ratio of the Gross enrolment ratio (%) of Lower middle income in 1982 to that in 1985?
Ensure brevity in your answer.  0.9. What is the ratio of the Gross enrolment ratio (%) of Burkina Faso in 1982 to that in 1985?
Make the answer very short. 0.78. What is the ratio of the Gross enrolment ratio (%) of High income: nonOECD in 1982 to that in 1986?
Offer a very short reply. 0.96. What is the ratio of the Gross enrolment ratio (%) in Lower middle income in 1982 to that in 1986?
Make the answer very short. 0.88. What is the ratio of the Gross enrolment ratio (%) in Burkina Faso in 1982 to that in 1986?
Offer a terse response. 0.65. What is the ratio of the Gross enrolment ratio (%) in Cuba in 1982 to that in 1986?
Offer a terse response. 0.96. What is the ratio of the Gross enrolment ratio (%) of High income: nonOECD in 1982 to that in 1987?
Provide a short and direct response. 0.96. What is the ratio of the Gross enrolment ratio (%) in Lower middle income in 1982 to that in 1987?
Your answer should be compact. 0.86. What is the ratio of the Gross enrolment ratio (%) of Burkina Faso in 1982 to that in 1987?
Your answer should be compact. 0.57. What is the ratio of the Gross enrolment ratio (%) in Cuba in 1982 to that in 1987?
Give a very brief answer. 0.95. What is the ratio of the Gross enrolment ratio (%) in High income: nonOECD in 1982 to that in 1988?
Make the answer very short. 0.96. What is the ratio of the Gross enrolment ratio (%) in Lower middle income in 1982 to that in 1988?
Give a very brief answer. 0.86. What is the ratio of the Gross enrolment ratio (%) of Burkina Faso in 1982 to that in 1988?
Your response must be concise. 0.51. What is the ratio of the Gross enrolment ratio (%) in Cuba in 1982 to that in 1988?
Make the answer very short. 0.93. What is the ratio of the Gross enrolment ratio (%) of Lower middle income in 1983 to that in 1984?
Provide a short and direct response. 0.97. What is the ratio of the Gross enrolment ratio (%) of Burkina Faso in 1983 to that in 1984?
Your answer should be compact. 0.93. What is the ratio of the Gross enrolment ratio (%) in Cuba in 1983 to that in 1984?
Your answer should be compact. 0.97. What is the ratio of the Gross enrolment ratio (%) of High income: nonOECD in 1983 to that in 1985?
Provide a short and direct response. 0.98. What is the ratio of the Gross enrolment ratio (%) in Lower middle income in 1983 to that in 1985?
Provide a short and direct response. 0.94. What is the ratio of the Gross enrolment ratio (%) of Burkina Faso in 1983 to that in 1985?
Offer a very short reply. 0.79. What is the ratio of the Gross enrolment ratio (%) in Cuba in 1983 to that in 1985?
Make the answer very short. 0.95. What is the ratio of the Gross enrolment ratio (%) in High income: nonOECD in 1983 to that in 1986?
Provide a succinct answer. 0.97. What is the ratio of the Gross enrolment ratio (%) in Lower middle income in 1983 to that in 1986?
Make the answer very short. 0.92. What is the ratio of the Gross enrolment ratio (%) in Burkina Faso in 1983 to that in 1986?
Offer a very short reply. 0.66. What is the ratio of the Gross enrolment ratio (%) in Cuba in 1983 to that in 1986?
Provide a short and direct response. 0.94. What is the ratio of the Gross enrolment ratio (%) of High income: nonOECD in 1983 to that in 1987?
Your answer should be very brief. 0.97. What is the ratio of the Gross enrolment ratio (%) of Lower middle income in 1983 to that in 1987?
Make the answer very short. 0.91. What is the ratio of the Gross enrolment ratio (%) of Burkina Faso in 1983 to that in 1987?
Offer a very short reply. 0.58. What is the ratio of the Gross enrolment ratio (%) of Cuba in 1983 to that in 1987?
Your answer should be compact. 0.93. What is the ratio of the Gross enrolment ratio (%) of High income: nonOECD in 1983 to that in 1988?
Offer a very short reply. 0.97. What is the ratio of the Gross enrolment ratio (%) of Lower middle income in 1983 to that in 1988?
Offer a very short reply. 0.9. What is the ratio of the Gross enrolment ratio (%) of Burkina Faso in 1983 to that in 1988?
Make the answer very short. 0.52. What is the ratio of the Gross enrolment ratio (%) of Cuba in 1983 to that in 1988?
Your response must be concise. 0.91. What is the ratio of the Gross enrolment ratio (%) of High income: nonOECD in 1984 to that in 1985?
Give a very brief answer. 0.99. What is the ratio of the Gross enrolment ratio (%) of Lower middle income in 1984 to that in 1985?
Your answer should be compact. 0.97. What is the ratio of the Gross enrolment ratio (%) of Burkina Faso in 1984 to that in 1985?
Ensure brevity in your answer.  0.84. What is the ratio of the Gross enrolment ratio (%) of Cuba in 1984 to that in 1985?
Make the answer very short. 0.99. What is the ratio of the Gross enrolment ratio (%) of High income: nonOECD in 1984 to that in 1986?
Your answer should be very brief. 0.98. What is the ratio of the Gross enrolment ratio (%) of Lower middle income in 1984 to that in 1986?
Offer a terse response. 0.95. What is the ratio of the Gross enrolment ratio (%) in Burkina Faso in 1984 to that in 1986?
Your answer should be compact. 0.71. What is the ratio of the Gross enrolment ratio (%) of Cuba in 1984 to that in 1986?
Your answer should be compact. 0.97. What is the ratio of the Gross enrolment ratio (%) in High income: nonOECD in 1984 to that in 1987?
Make the answer very short. 0.98. What is the ratio of the Gross enrolment ratio (%) of Lower middle income in 1984 to that in 1987?
Offer a very short reply. 0.93. What is the ratio of the Gross enrolment ratio (%) of Burkina Faso in 1984 to that in 1987?
Provide a short and direct response. 0.62. What is the ratio of the Gross enrolment ratio (%) in Cuba in 1984 to that in 1987?
Give a very brief answer. 0.96. What is the ratio of the Gross enrolment ratio (%) in High income: nonOECD in 1984 to that in 1988?
Keep it short and to the point. 0.98. What is the ratio of the Gross enrolment ratio (%) of Lower middle income in 1984 to that in 1988?
Offer a terse response. 0.93. What is the ratio of the Gross enrolment ratio (%) of Burkina Faso in 1984 to that in 1988?
Keep it short and to the point. 0.55. What is the ratio of the Gross enrolment ratio (%) in Cuba in 1984 to that in 1988?
Your response must be concise. 0.94. What is the ratio of the Gross enrolment ratio (%) in High income: nonOECD in 1985 to that in 1986?
Provide a short and direct response. 0.99. What is the ratio of the Gross enrolment ratio (%) in Lower middle income in 1985 to that in 1986?
Provide a short and direct response. 0.98. What is the ratio of the Gross enrolment ratio (%) of Burkina Faso in 1985 to that in 1986?
Give a very brief answer. 0.84. What is the ratio of the Gross enrolment ratio (%) of High income: nonOECD in 1985 to that in 1987?
Give a very brief answer. 0.99. What is the ratio of the Gross enrolment ratio (%) in Lower middle income in 1985 to that in 1987?
Keep it short and to the point. 0.96. What is the ratio of the Gross enrolment ratio (%) of Burkina Faso in 1985 to that in 1987?
Your answer should be very brief. 0.74. What is the ratio of the Gross enrolment ratio (%) of Cuba in 1985 to that in 1987?
Your response must be concise. 0.97. What is the ratio of the Gross enrolment ratio (%) in High income: nonOECD in 1985 to that in 1988?
Provide a short and direct response. 1. What is the ratio of the Gross enrolment ratio (%) in Lower middle income in 1985 to that in 1988?
Offer a very short reply. 0.96. What is the ratio of the Gross enrolment ratio (%) of Burkina Faso in 1985 to that in 1988?
Your answer should be very brief. 0.66. What is the ratio of the Gross enrolment ratio (%) in Cuba in 1985 to that in 1988?
Ensure brevity in your answer.  0.95. What is the ratio of the Gross enrolment ratio (%) in Lower middle income in 1986 to that in 1987?
Keep it short and to the point. 0.98. What is the ratio of the Gross enrolment ratio (%) in Burkina Faso in 1986 to that in 1987?
Make the answer very short. 0.88. What is the ratio of the Gross enrolment ratio (%) of Cuba in 1986 to that in 1987?
Offer a very short reply. 0.99. What is the ratio of the Gross enrolment ratio (%) of High income: nonOECD in 1986 to that in 1988?
Keep it short and to the point. 1. What is the ratio of the Gross enrolment ratio (%) in Lower middle income in 1986 to that in 1988?
Provide a short and direct response. 0.98. What is the ratio of the Gross enrolment ratio (%) in Burkina Faso in 1986 to that in 1988?
Make the answer very short. 0.78. What is the ratio of the Gross enrolment ratio (%) of Cuba in 1986 to that in 1988?
Offer a very short reply. 0.97. What is the ratio of the Gross enrolment ratio (%) in High income: nonOECD in 1987 to that in 1988?
Make the answer very short. 1. What is the ratio of the Gross enrolment ratio (%) of Lower middle income in 1987 to that in 1988?
Provide a succinct answer. 1. What is the ratio of the Gross enrolment ratio (%) of Burkina Faso in 1987 to that in 1988?
Keep it short and to the point. 0.89. What is the ratio of the Gross enrolment ratio (%) in Cuba in 1987 to that in 1988?
Keep it short and to the point. 0.98. What is the difference between the highest and the second highest Gross enrolment ratio (%) of High income: nonOECD?
Ensure brevity in your answer.  0.01. What is the difference between the highest and the second highest Gross enrolment ratio (%) of Lower middle income?
Your answer should be compact. 0.12. What is the difference between the highest and the second highest Gross enrolment ratio (%) of Burkina Faso?
Provide a short and direct response. 0.65. What is the difference between the highest and the second highest Gross enrolment ratio (%) of Cuba?
Your answer should be compact. 1.56. What is the difference between the highest and the lowest Gross enrolment ratio (%) of High income: nonOECD?
Provide a short and direct response. 3.54. What is the difference between the highest and the lowest Gross enrolment ratio (%) of Lower middle income?
Offer a terse response. 5.47. What is the difference between the highest and the lowest Gross enrolment ratio (%) in Burkina Faso?
Ensure brevity in your answer.  2.85. What is the difference between the highest and the lowest Gross enrolment ratio (%) of Cuba?
Offer a very short reply. 7.88. 